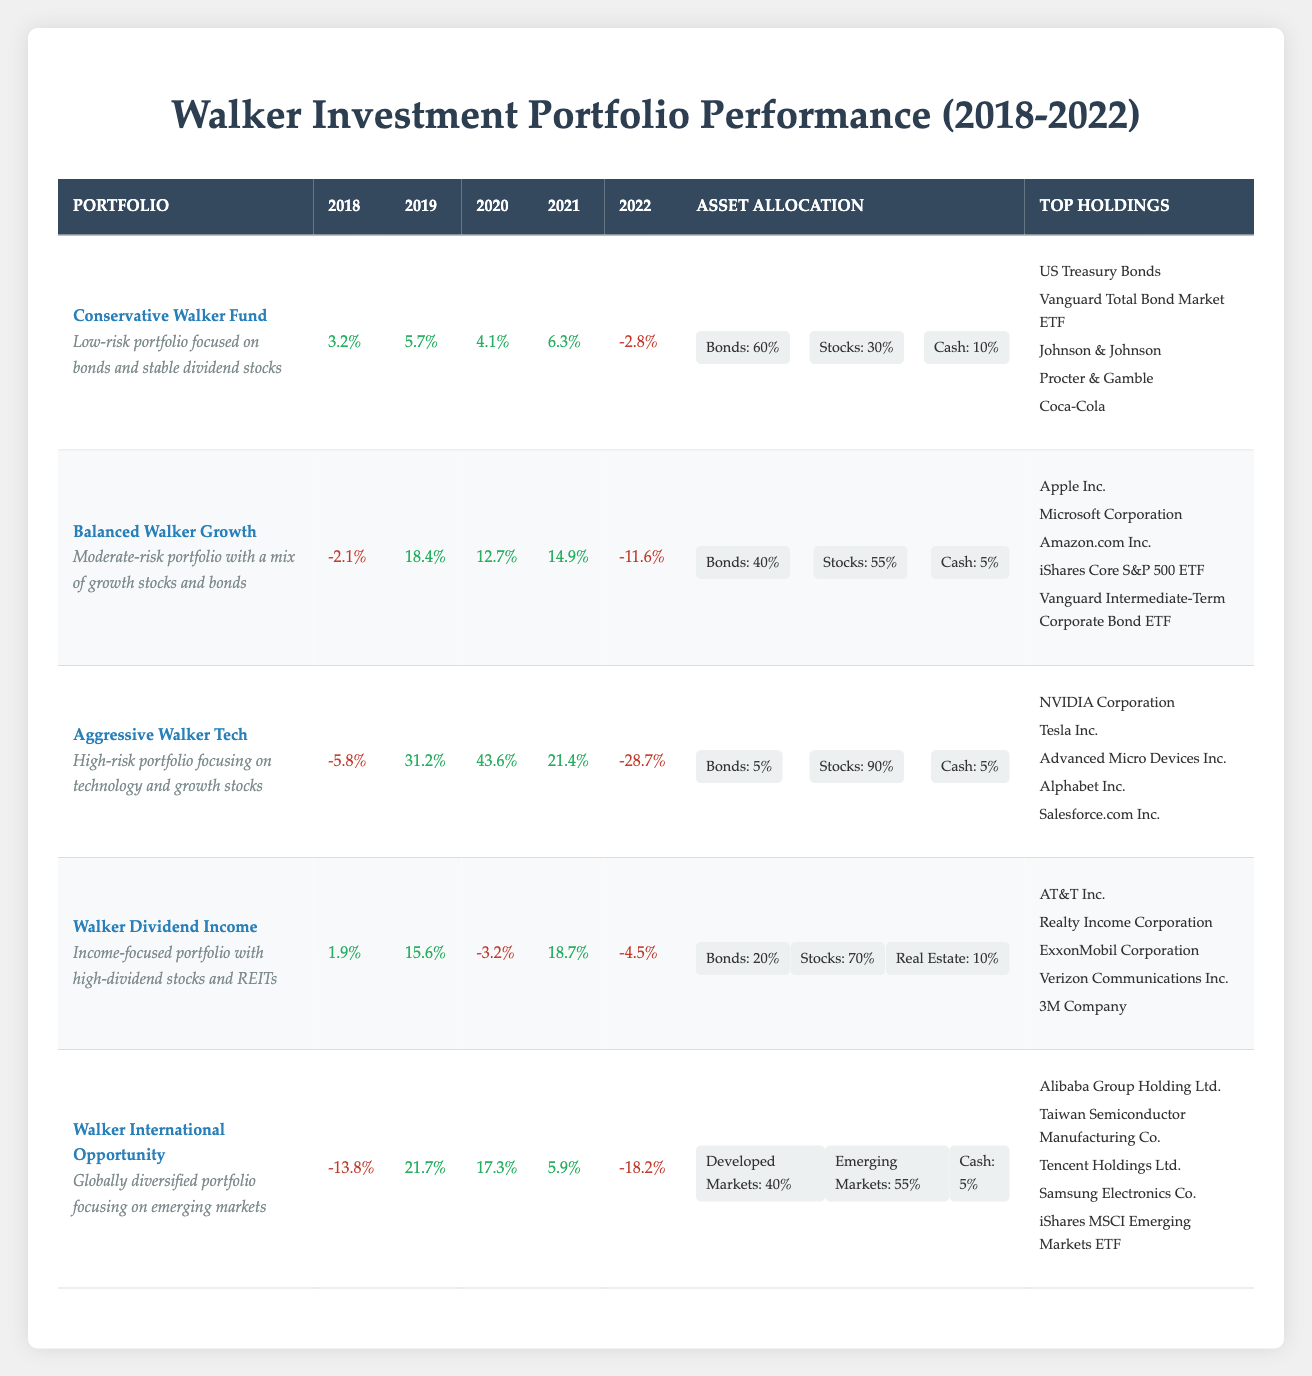What was the highest annual return for the Conservative Walker Fund? The annual returns for the Conservative Walker Fund are 3.2%, 5.7%, 4.1%, 6.3%, and -2.8% from 2018 to 2022. The highest return is 6.3% in 2021.
Answer: 6.3% Which portfolio had the lowest total return over the five years? To find the total return, we need to sum the annual returns over the years. For the Aggressive Walker Tech, the returns are: -5.8% + 31.2% + 43.6% + 21.4% - 28.7% = 62.7%. Doing this for all portfolios, the Walker International Opportunity has the lowest total return of -3.1%.
Answer: Walker International Opportunity Did the Balanced Walker Growth portfolio have a positive return in every year? Checking the annual returns for the Balanced Walker Growth portfolio: -2.1%, 18.4%, 12.7%, 14.9%, and -11.6%. Since it has two negative returns, it did not have a positive return in every year.
Answer: No What is the average annual return for the Walker Dividend Income portfolio? The annual returns for Wilson Dividend Income are calculated as follows: (1.9% + 15.6% - 3.2% + 18.7% - 4.5%) / 5 = 5.5%. Thus, summing them gives 28.5%, and dividing by 5 yields an average of 5.7%.
Answer: 5.7% Which portfolio had the largest year-to-year increase in returns? To find the largest increase, examine the annual returns for each portfolio and calculate the differences between consecutive years. The Aggressive Walker Tech had an increase from 2018 to 2019 of 37%, which is the largest jump among the portfolios.
Answer: Aggressive Walker Tech What percentage of the Conservative Walker Fund is allocated to stocks? The asset allocation for the Conservative Walker Fund states that 30% is allocated to stocks. This is clearly visible in the asset allocation section of the table.
Answer: 30% Which portfolio had the worst return in 2022? In 2022, the returns from each portfolio are: -2.8% (Conservative Walker Fund), -11.6% (Balanced Walker Growth), -28.7% (Aggressive Walker Tech), -4.5% (Walker Dividend Income), and -18.2% (Walker International Opportunity). The Aggressive Walker Tech had the worst return at -28.7%.
Answer: Aggressive Walker Tech What is the difference in average return between the Conservative Walker Fund and the Balanced Walker Growth? The average return for the Conservative Walker Fund is calculated as (3.2% + 5.7% + 4.1% + 6.3% - 2.8%) / 5 = 3.51%. For the Balanced Walker Growth, the average return is (-2.1% + 18.4% + 12.7% + 14.9% - 11.6%) / 5 = 6.46%. The difference is 6.46% - 3.51% = 2.95%.
Answer: 2.95% 